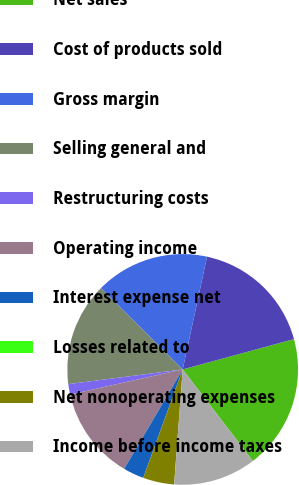Convert chart to OTSL. <chart><loc_0><loc_0><loc_500><loc_500><pie_chart><fcel>Net sales<fcel>Cost of products sold<fcel>Gross margin<fcel>Selling general and<fcel>Restructuring costs<fcel>Operating income<fcel>Interest expense net<fcel>Losses related to<fcel>Net nonoperating expenses<fcel>Income before income taxes<nl><fcel>18.83%<fcel>17.38%<fcel>15.93%<fcel>14.49%<fcel>1.46%<fcel>13.04%<fcel>2.91%<fcel>0.01%<fcel>4.36%<fcel>11.59%<nl></chart> 